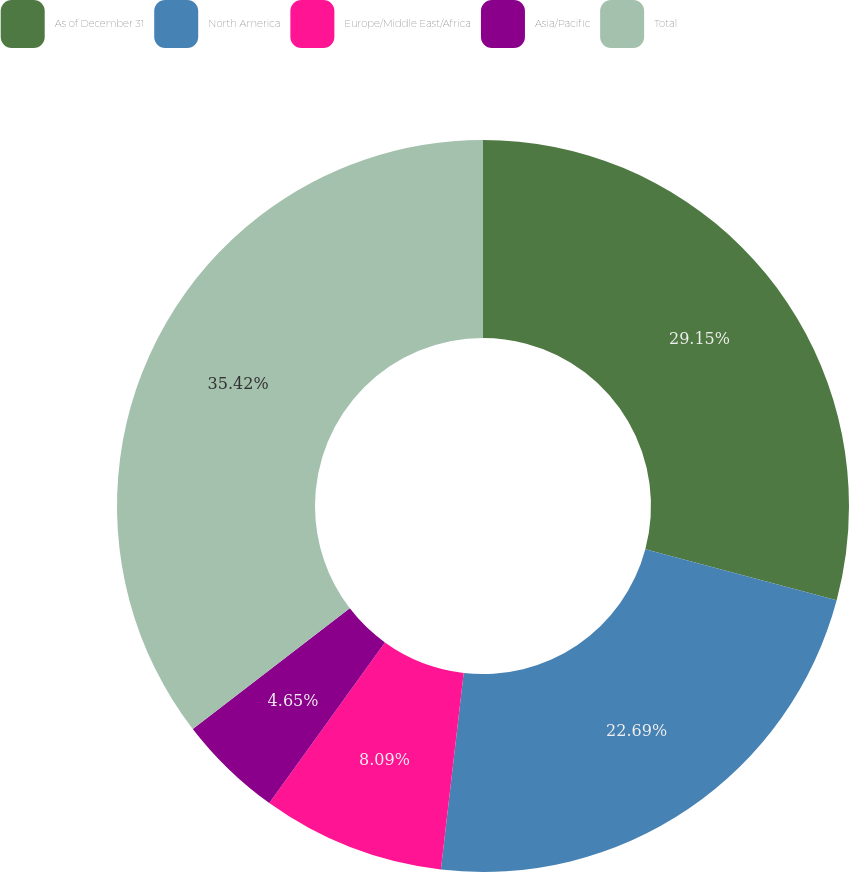Convert chart. <chart><loc_0><loc_0><loc_500><loc_500><pie_chart><fcel>As of December 31<fcel>North America<fcel>Europe/Middle East/Africa<fcel>Asia/Pacific<fcel>Total<nl><fcel>29.15%<fcel>22.69%<fcel>8.09%<fcel>4.65%<fcel>35.43%<nl></chart> 